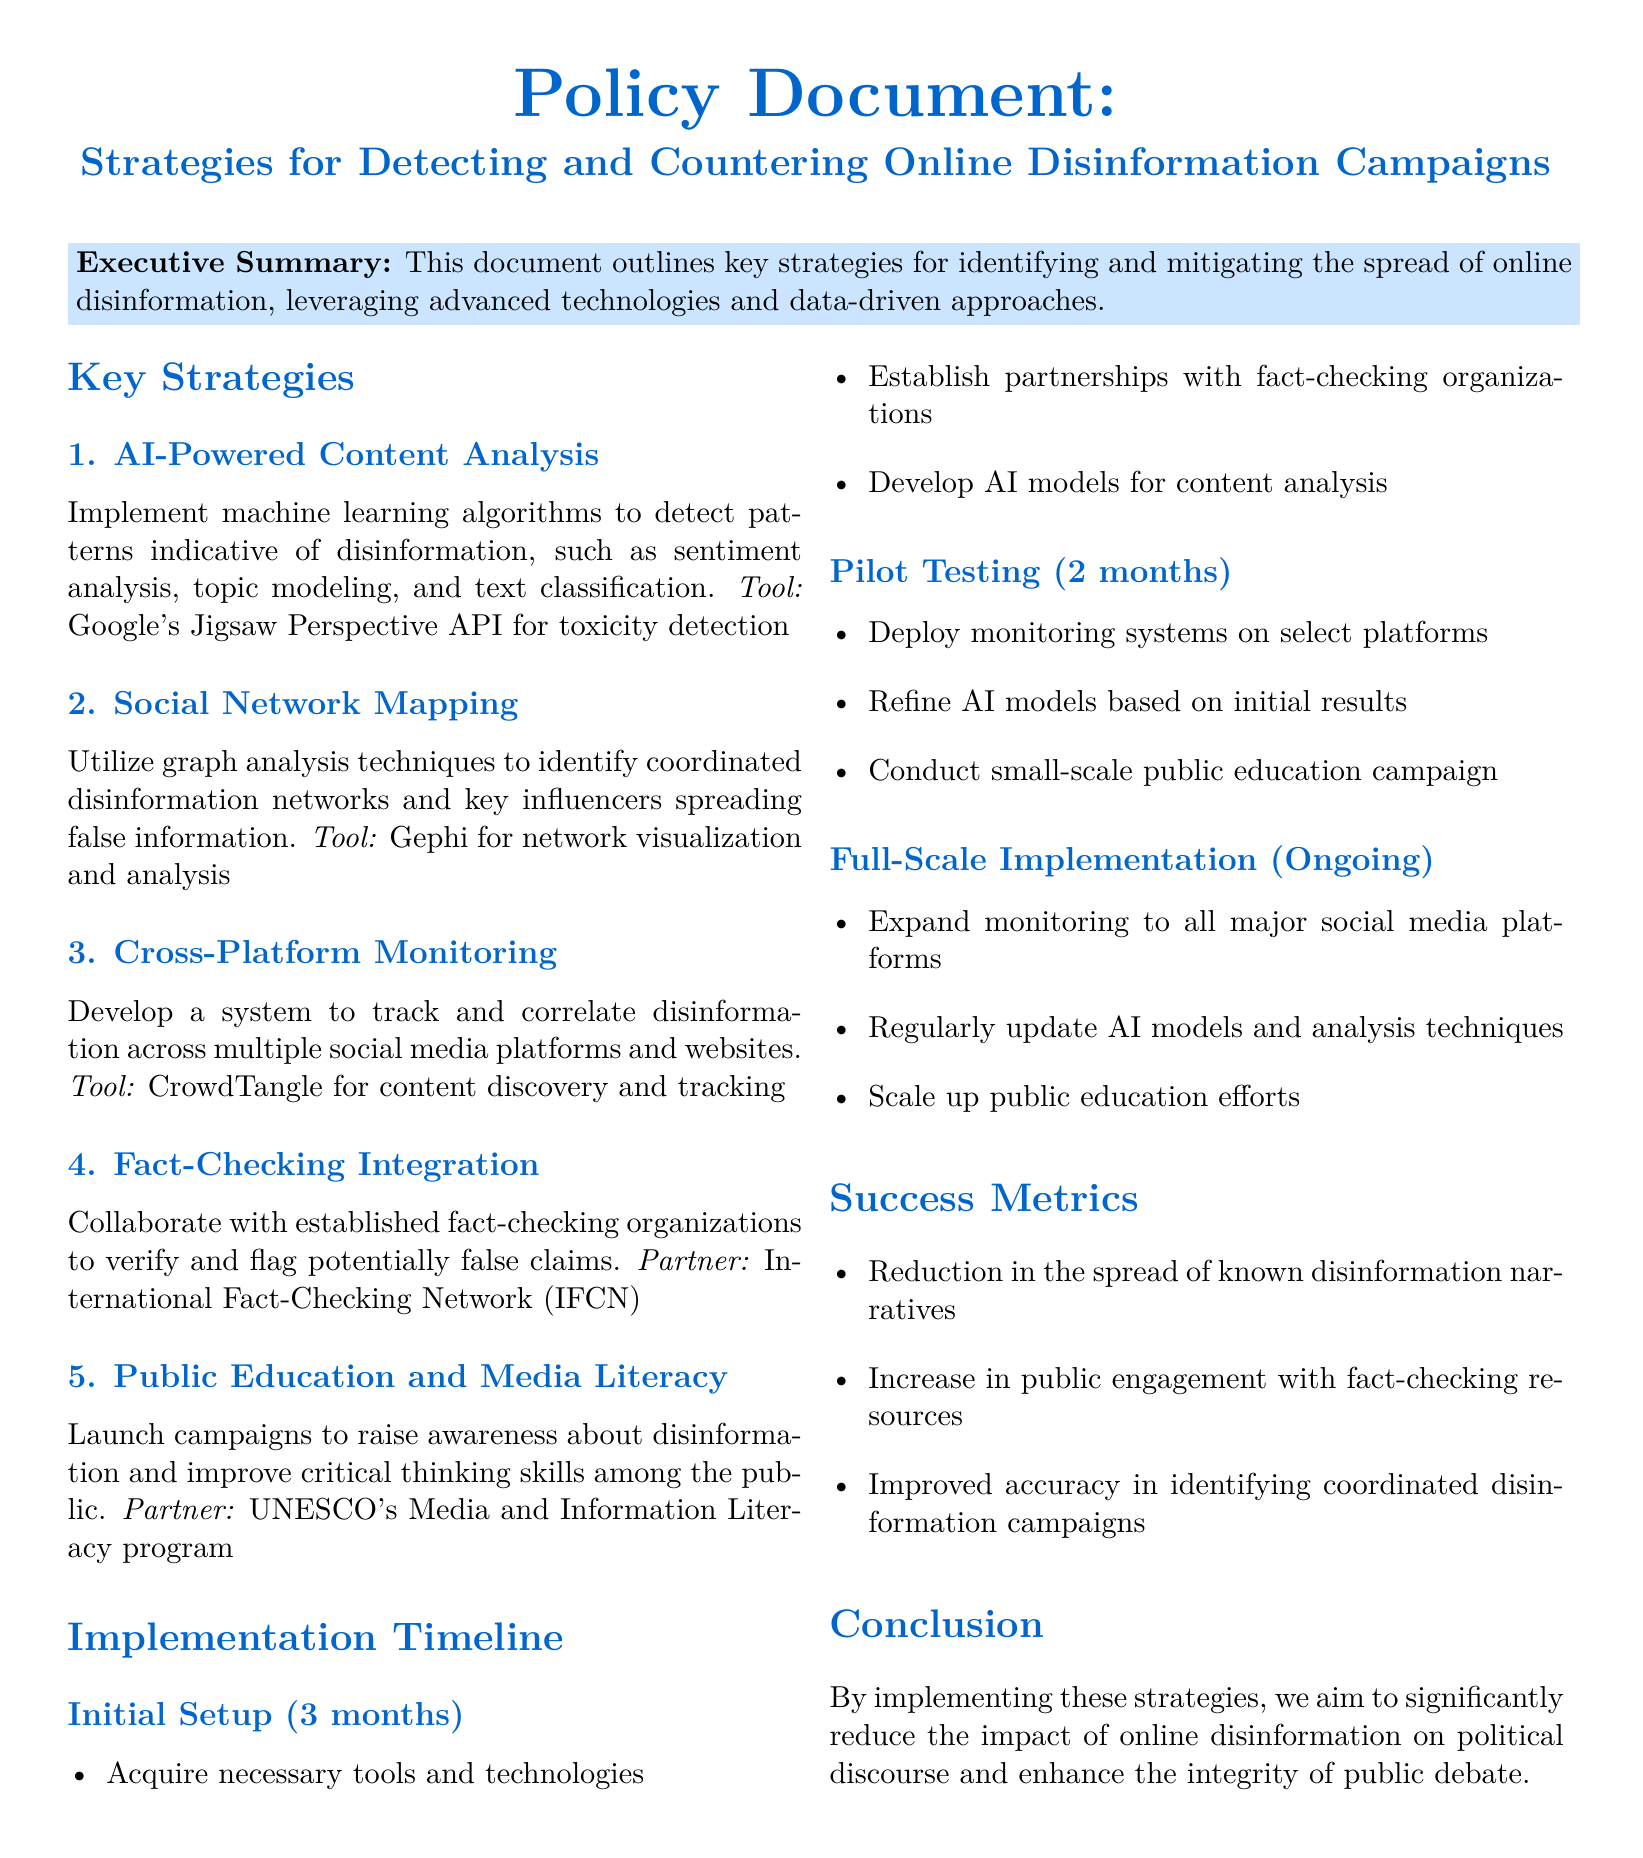What is the title of the document? The title of the document is presented at the beginning, which indicates the primary focus of the policy document.
Answer: Strategies for Detecting and Countering Online Disinformation Campaigns What is the first key strategy listed? The first key strategy is clearly identified in the section on key strategies in the document.
Answer: AI-Powered Content Analysis How long is the initial setup expected to take? The timeline for the initial setup is indicated in the implementation timeline section of the document.
Answer: 3 months Which tool is suggested for social network mapping? The document names a specific tool under the second key strategy for social network mapping.
Answer: Gephi What is one success metric mentioned? The success metrics are outlined in a dedicated section, providing measurable outcomes.
Answer: Reduction in the spread of known disinformation narratives Who is the partner organization mentioned for fact-checking integration? The document specifies a partnership for fact-checking, highlighting collaboration in countering disinformation.
Answer: International Fact-Checking Network (IFCN) What is the duration of the pilot testing phase? The duration for the pilot testing phase is listed in the implementation timeline, showing the time allocated for this stage.
Answer: 2 months What is one goal of public education and media literacy campaigns? The goals of public education efforts are described in the section addressing public engagement and literacy.
Answer: Raise awareness about disinformation What type of models will be developed in the initial setup? The specific type of models that will be developed is mentioned under the initial setup section of the implementation timeline.
Answer: AI models for content analysis 